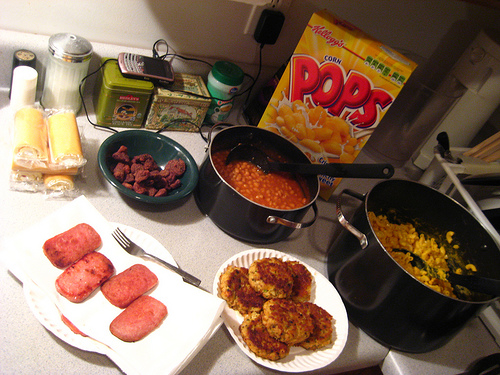<image>
Is the cereal in the pot? No. The cereal is not contained within the pot. These objects have a different spatial relationship. Is there a cereal behind the pot? Yes. From this viewpoint, the cereal is positioned behind the pot, with the pot partially or fully occluding the cereal. Is the box on the table? Yes. Looking at the image, I can see the box is positioned on top of the table, with the table providing support. Is there a fork on the table? Yes. Looking at the image, I can see the fork is positioned on top of the table, with the table providing support. 